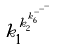<formula> <loc_0><loc_0><loc_500><loc_500>k _ { 1 } ^ { k _ { 2 } ^ { k _ { 6 } ^ { - ^ { - ^ { - } } } } }</formula> 